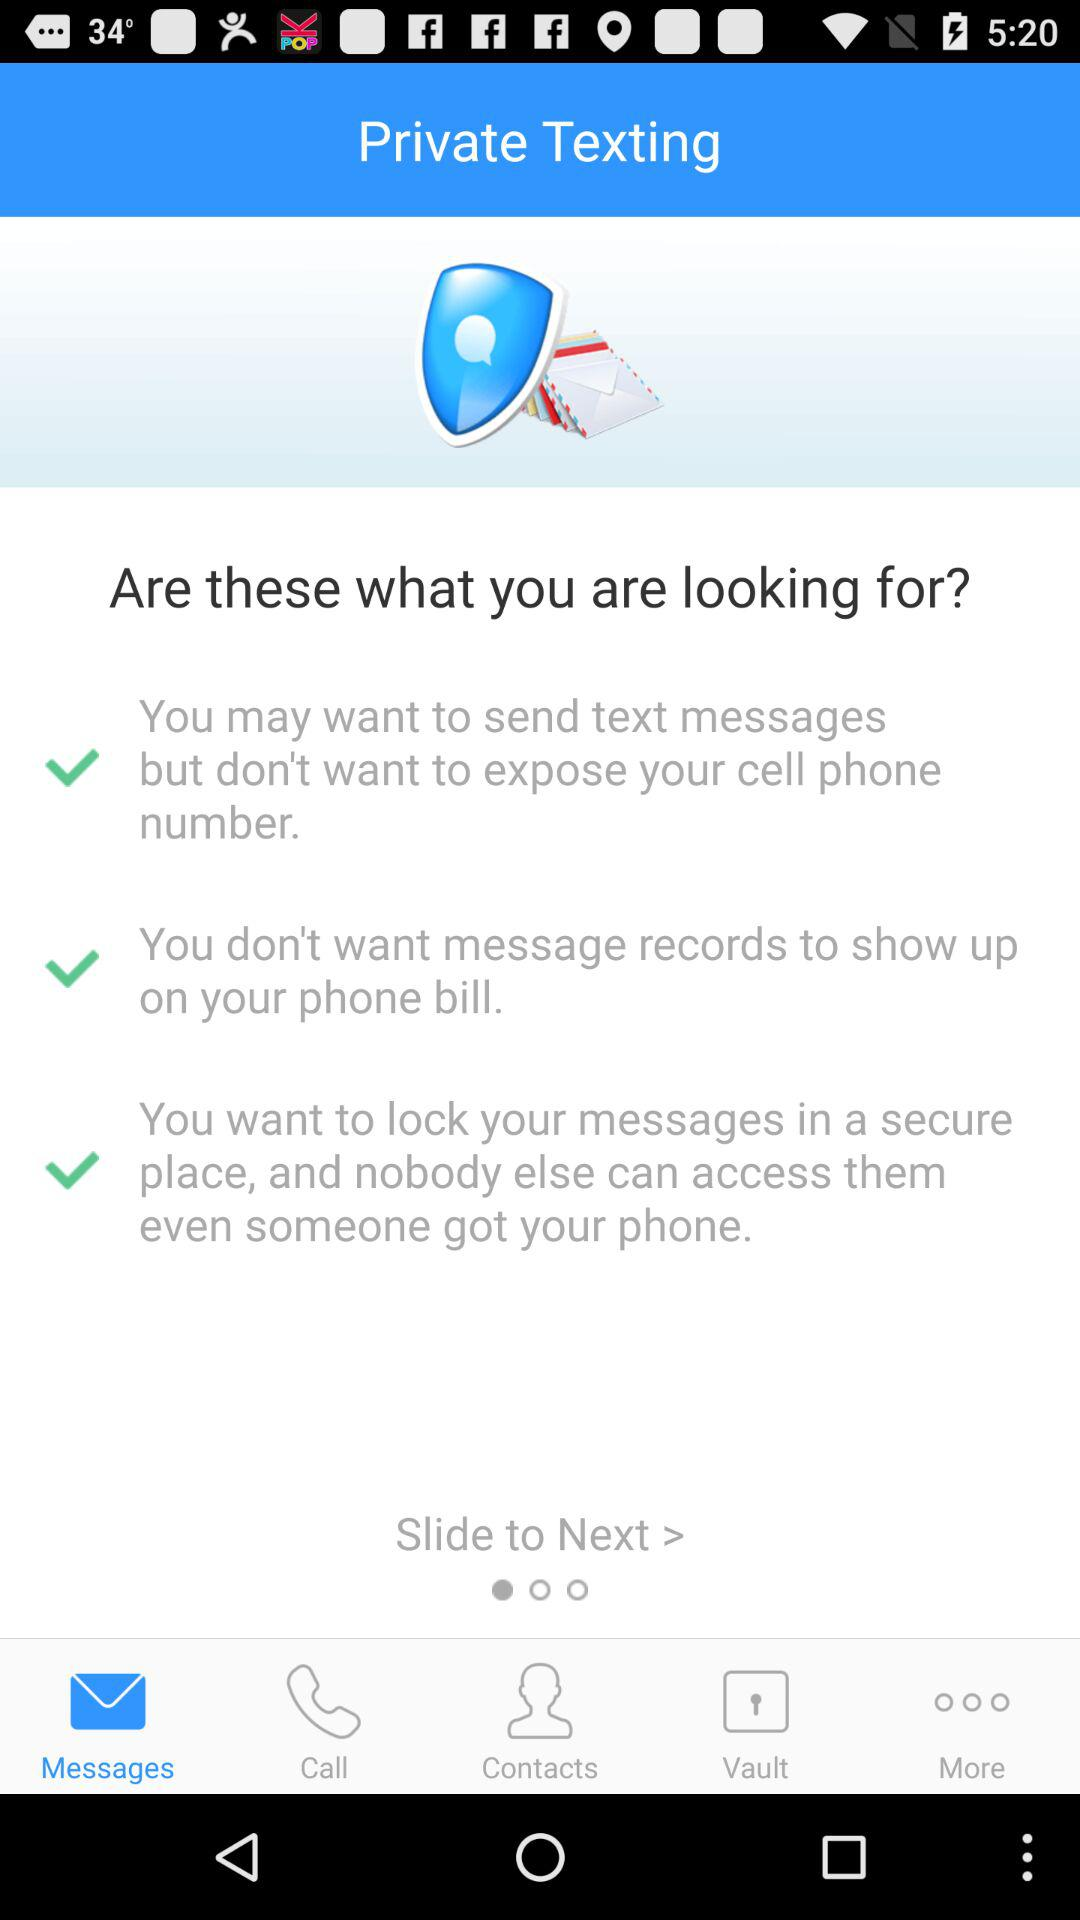Which tab has been selected? The selected tab is "Messages". 